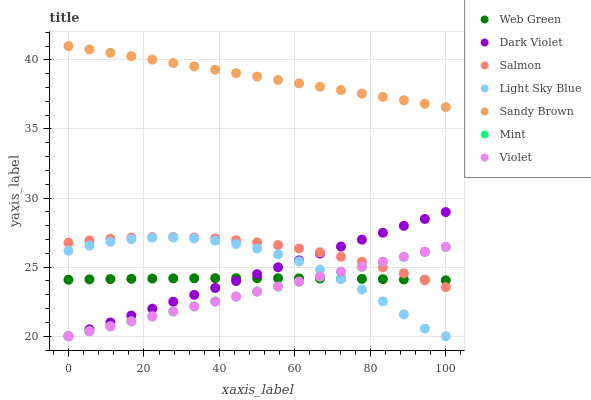Does Mint have the minimum area under the curve?
Answer yes or no. Yes. Does Sandy Brown have the maximum area under the curve?
Answer yes or no. Yes. Does Salmon have the minimum area under the curve?
Answer yes or no. No. Does Salmon have the maximum area under the curve?
Answer yes or no. No. Is Mint the smoothest?
Answer yes or no. Yes. Is Light Sky Blue the roughest?
Answer yes or no. Yes. Is Salmon the smoothest?
Answer yes or no. No. Is Salmon the roughest?
Answer yes or no. No. Does Mint have the lowest value?
Answer yes or no. Yes. Does Salmon have the lowest value?
Answer yes or no. No. Does Sandy Brown have the highest value?
Answer yes or no. Yes. Does Salmon have the highest value?
Answer yes or no. No. Is Light Sky Blue less than Salmon?
Answer yes or no. Yes. Is Sandy Brown greater than Light Sky Blue?
Answer yes or no. Yes. Does Web Green intersect Dark Violet?
Answer yes or no. Yes. Is Web Green less than Dark Violet?
Answer yes or no. No. Is Web Green greater than Dark Violet?
Answer yes or no. No. Does Light Sky Blue intersect Salmon?
Answer yes or no. No. 